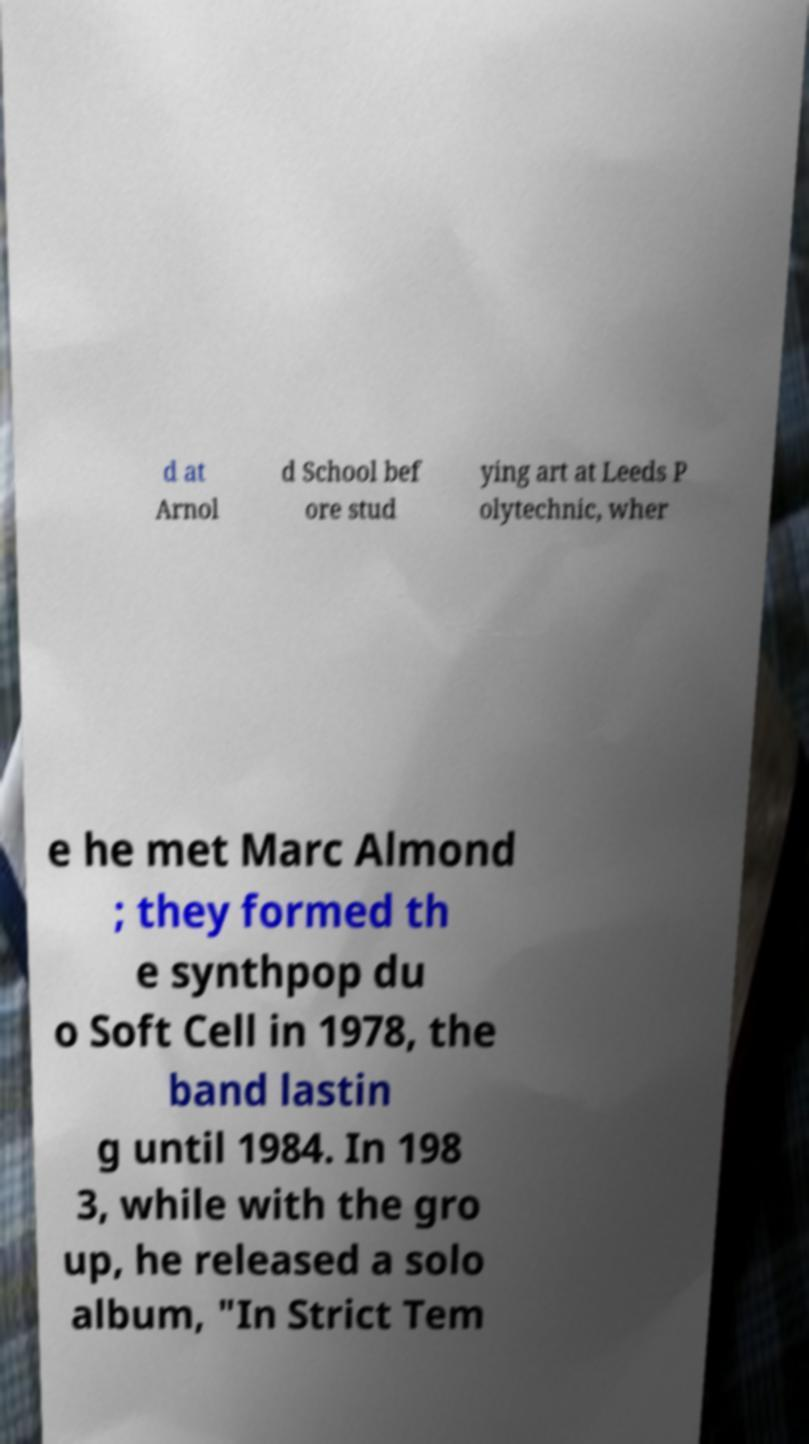Please read and relay the text visible in this image. What does it say? d at Arnol d School bef ore stud ying art at Leeds P olytechnic, wher e he met Marc Almond ; they formed th e synthpop du o Soft Cell in 1978, the band lastin g until 1984. In 198 3, while with the gro up, he released a solo album, "In Strict Tem 